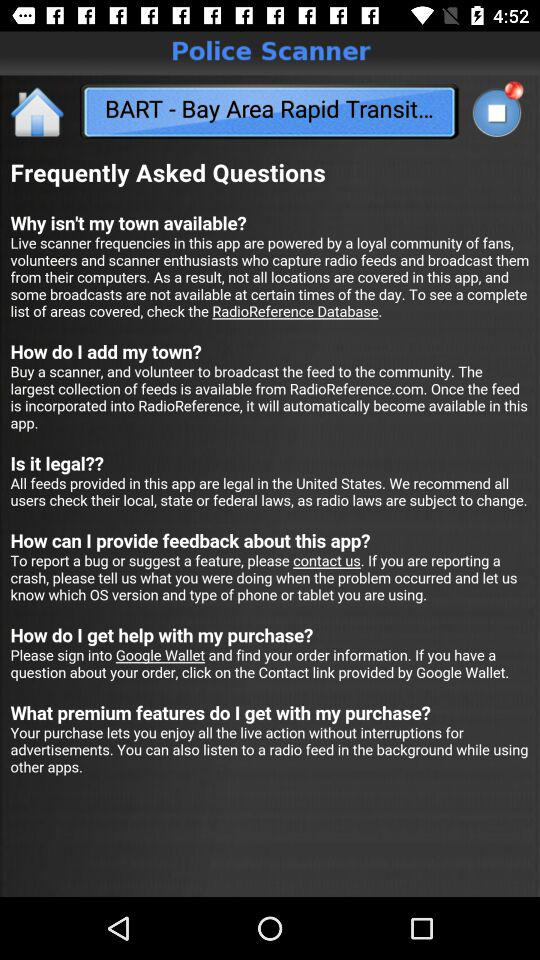What is the application name? The application name is "Police Scanner". 